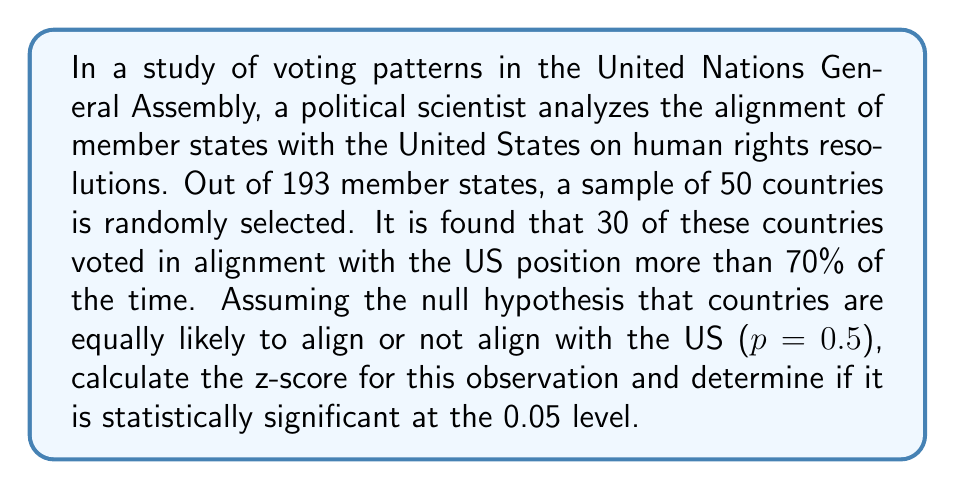What is the answer to this math problem? To solve this problem, we'll use the following steps:

1. Identify the parameters:
   - Sample size: $n = 50$
   - Number of successes (countries aligning with US): $x = 30$
   - Hypothesized probability of success: $p_0 = 0.5$

2. Calculate the sample proportion:
   $\hat{p} = \frac{x}{n} = \frac{30}{50} = 0.6$

3. Calculate the standard error under the null hypothesis:
   $SE = \sqrt{\frac{p_0(1-p_0)}{n}} = \sqrt{\frac{0.5(1-0.5)}{50}} = \sqrt{\frac{0.25}{50}} = 0.0707$

4. Calculate the z-score:
   $z = \frac{\hat{p} - p_0}{SE} = \frac{0.6 - 0.5}{0.0707} = 1.414$

5. Determine the critical value for a two-tailed test at the 0.05 level:
   The critical z-value for a 0.05 significance level in a two-tailed test is ±1.96.

6. Compare the calculated z-score to the critical value:
   $|1.414| < 1.96$

Therefore, the observed proportion is not statistically significant at the 0.05 level, as the absolute value of the calculated z-score (1.414) is less than the critical value (1.96).
Answer: The z-score is 1.414. This result is not statistically significant at the 0.05 level, as $|1.414| < 1.96$. 